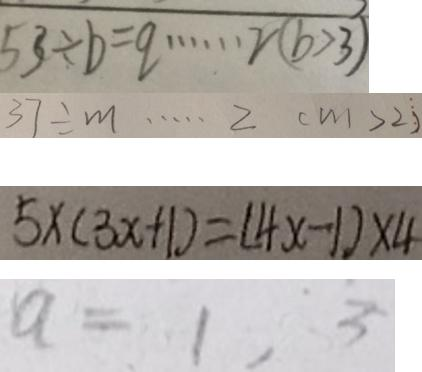Convert formula to latex. <formula><loc_0><loc_0><loc_500><loc_500>5 3 \div b = q \cdots 2 ( b > 3 ) 
 3 7 \div m \cdots 2 ( m > 2 ) 
 5 \times ( 3 x + 1 ) = ( 4 x - 1 ) \times 4 
 a = 1 , 3</formula> 